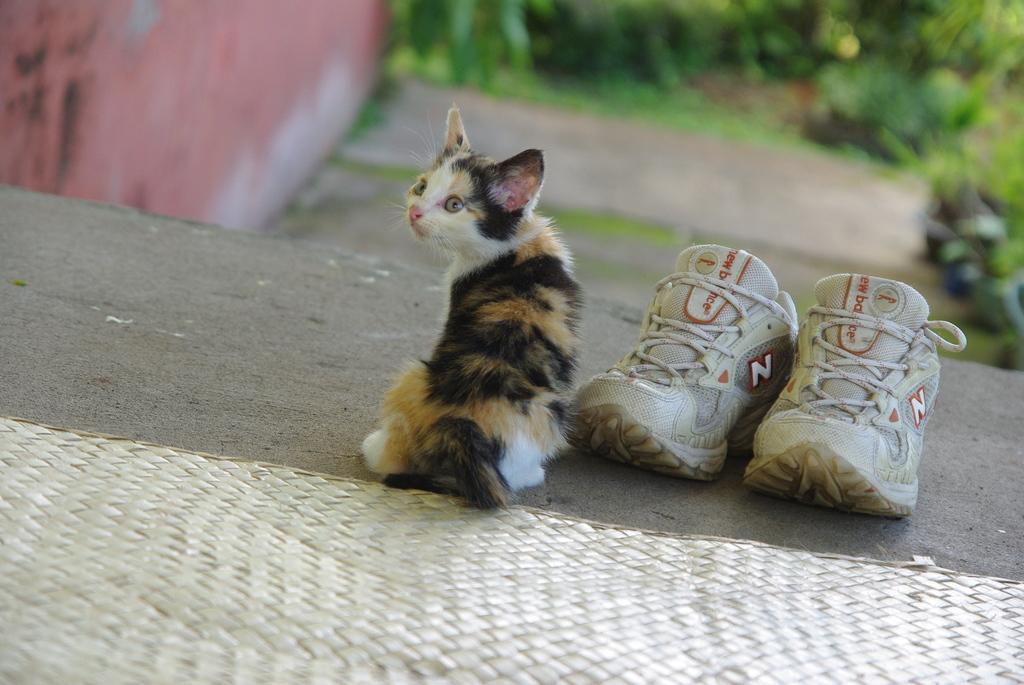Can you describe this image briefly? This image is taken outdoors. At the bottom of the image there is a mat. In the background there is a wall and there are a few plants on the ground. In the middle of the image there is a cat on the floor and there are two shoes beside the cat on the floor. 